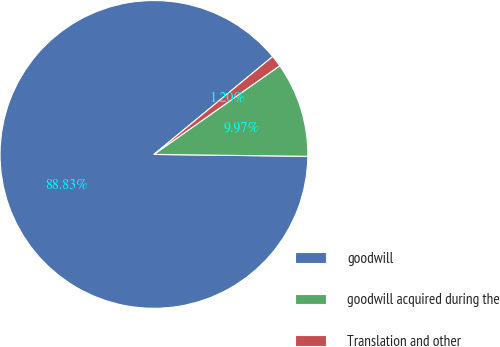Convert chart to OTSL. <chart><loc_0><loc_0><loc_500><loc_500><pie_chart><fcel>goodwill<fcel>goodwill acquired during the<fcel>Translation and other<nl><fcel>88.83%<fcel>9.97%<fcel>1.2%<nl></chart> 